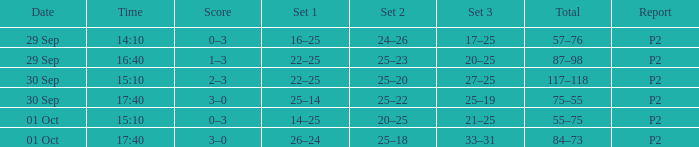What Score has a time of 14:10? 0–3. 